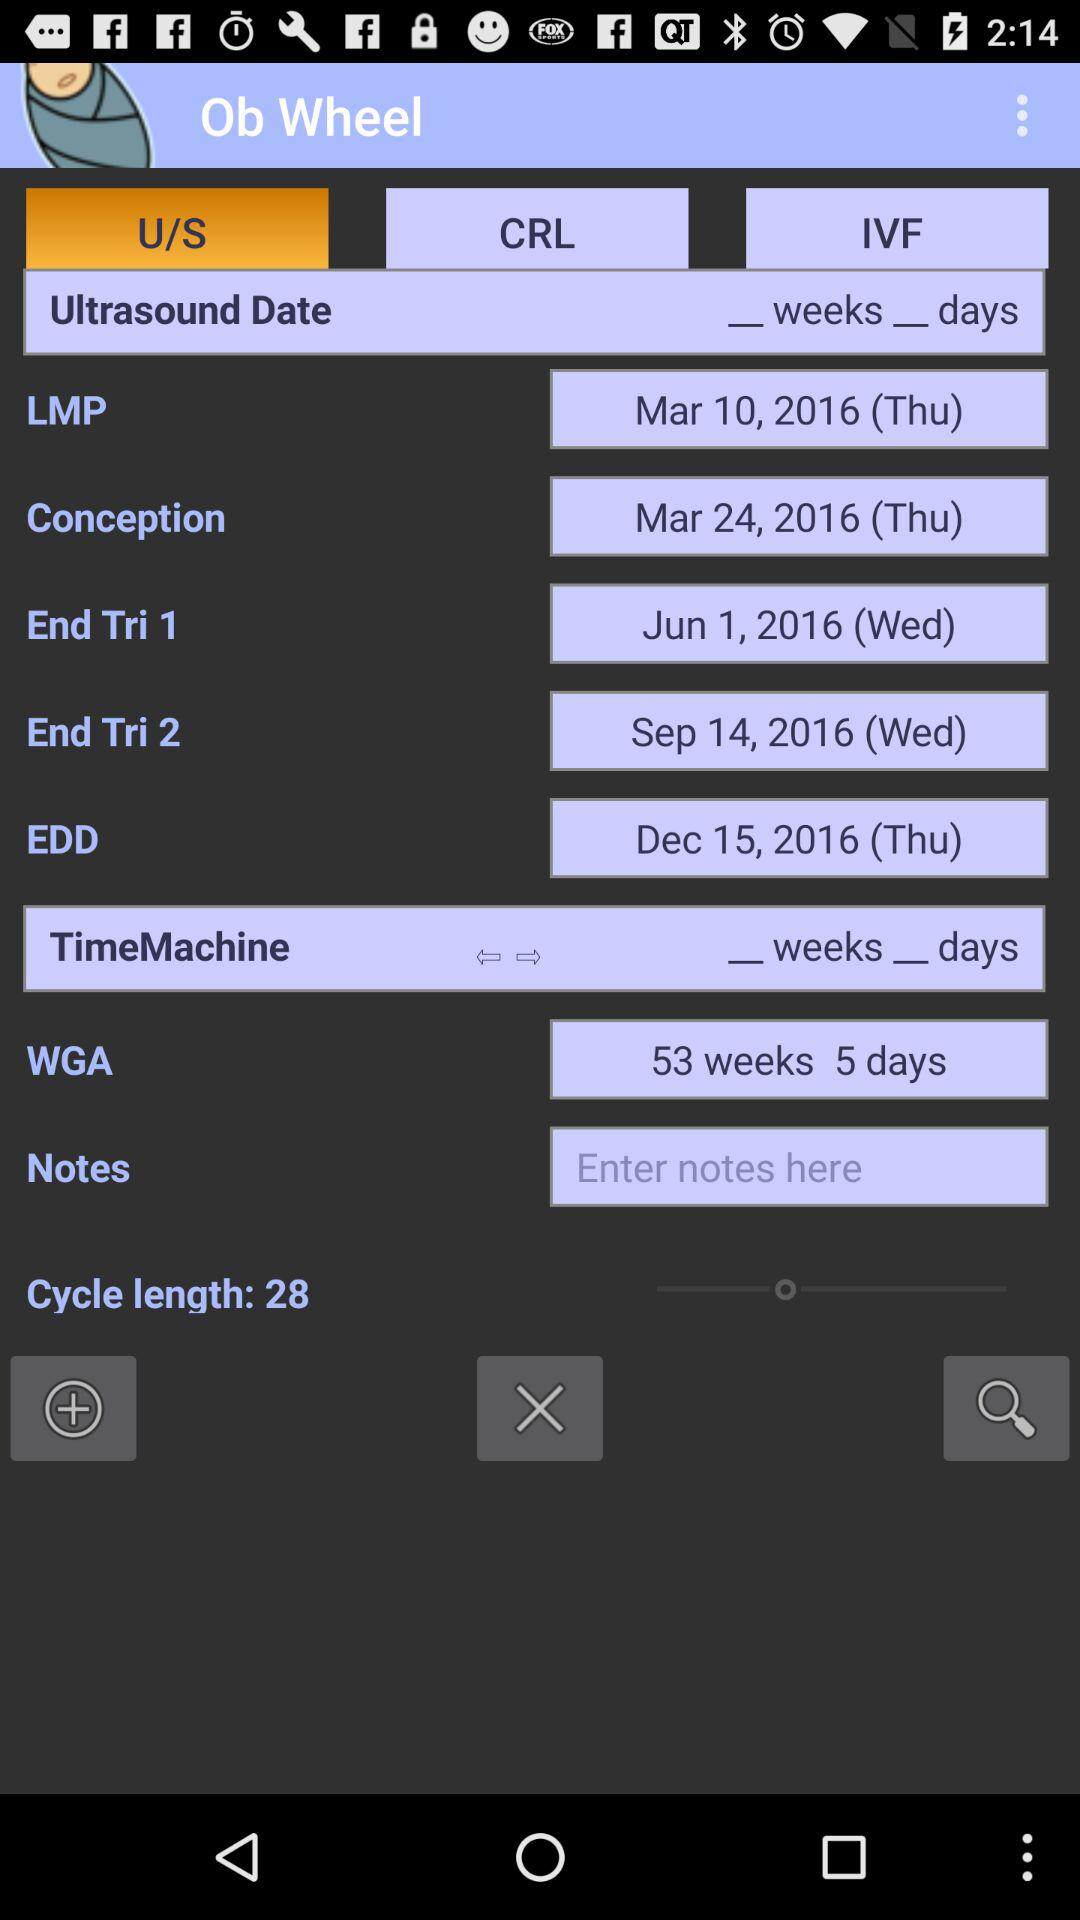What is the date of conception? The date of conception is Thursday, March 24, 2016. 